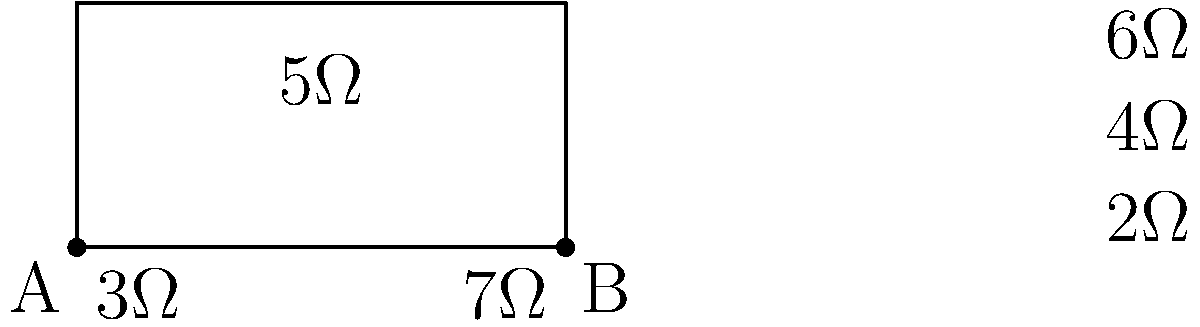As a father concerned about your daughter's electrical engineering studies, you want to ensure she understands basic circuit concepts. Given the series circuit diagram above, calculate the total resistance between points A and B. How would this knowledge help in designing safer home electrical systems? To calculate the total resistance of a series circuit, we need to sum up all the individual resistances. Let's break it down step-by-step:

1. Identify all resistors in the circuit:
   - $R_1 = 3\Omega$
   - $R_2 = 7\Omega$
   - $R_3 = 2\Omega$
   - $R_4 = 4\Omega$
   - $R_5 = 6\Omega$
   - $R_6 = 5\Omega$

2. Apply the formula for total resistance in a series circuit:
   $R_{total} = R_1 + R_2 + R_3 + R_4 + R_5 + R_6$

3. Substitute the values:
   $R_{total} = 3\Omega + 7\Omega + 2\Omega + 4\Omega + 6\Omega + 5\Omega$

4. Calculate the sum:
   $R_{total} = 27\Omega$

Understanding series circuits is crucial for designing safer home electrical systems because:
- It helps in calculating voltage drops across different components
- It aids in proper selection of wire gauges and circuit breakers
- It ensures that the total current in the circuit doesn't exceed safe limits
- It helps in designing proper grounding systems to prevent electrical shocks
Answer: $27\Omega$ 